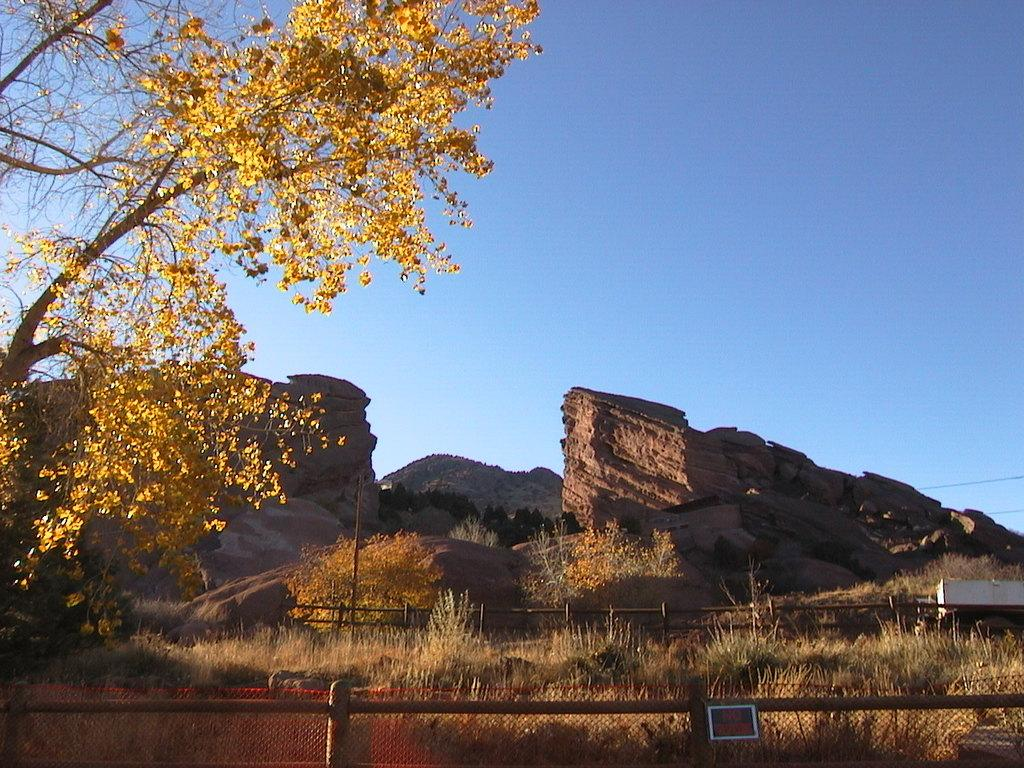What type of structure can be seen in the image? There is a fence in the image. What is attached to a rod in the image? There is a board attached to a rod in the image. What can be seen in the background of the image? There are many trees, mountains, and the sky visible in the background of the image. What color shade is present in the background of the image? There is a white color shade in the background of the image. How does the knowledge of the mountains affect the shelf in the image? There is no shelf present in the image, and the knowledge of the mountains does not affect any objects in the image. What type of fog can be seen in the image? There is no fog present in the image. 